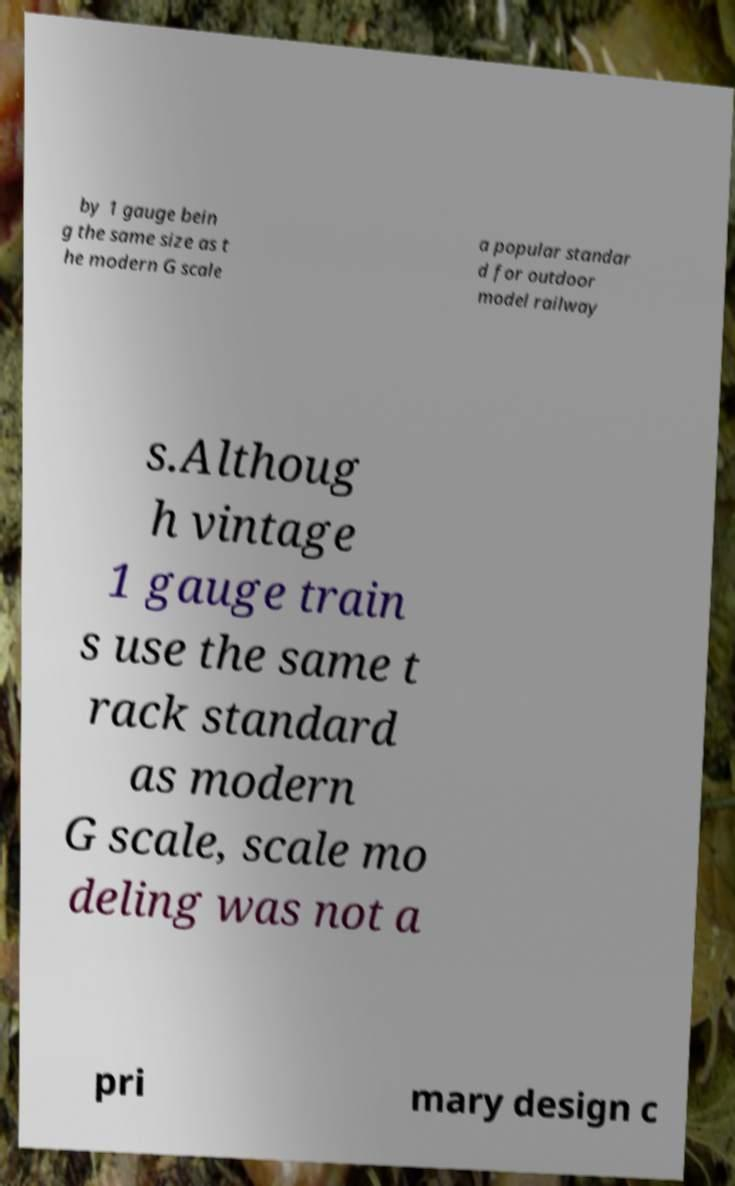Could you extract and type out the text from this image? by 1 gauge bein g the same size as t he modern G scale a popular standar d for outdoor model railway s.Althoug h vintage 1 gauge train s use the same t rack standard as modern G scale, scale mo deling was not a pri mary design c 